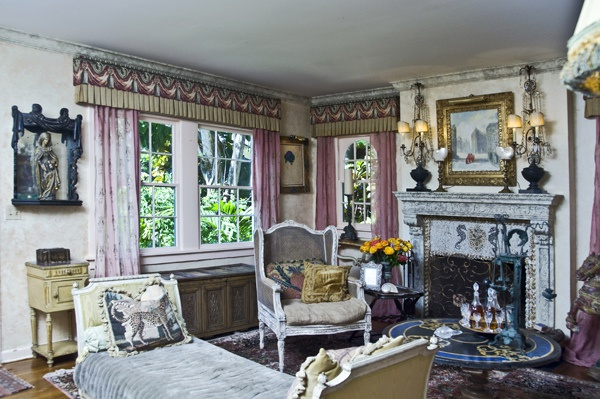Describe the objects in this image and their specific colors. I can see bed in darkgray, lightgray, and gray tones, chair in darkgray, gray, black, and lightgray tones, couch in darkgray, black, and gray tones, potted plant in darkgray, black, orange, and olive tones, and bottle in darkgray, black, and gray tones in this image. 